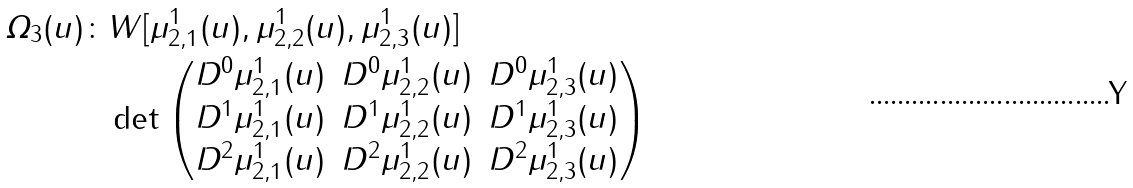Convert formula to latex. <formula><loc_0><loc_0><loc_500><loc_500>\varOmega _ { 3 } ( u ) \colon & W [ \mu ^ { 1 } _ { 2 , 1 } ( u ) , \mu ^ { 1 } _ { 2 , 2 } ( u ) , \mu ^ { 1 } _ { 2 , 3 } ( u ) ] \\ & \det \begin{pmatrix} D ^ { 0 } \mu ^ { 1 } _ { 2 , 1 } ( u ) & D ^ { 0 } \mu ^ { 1 } _ { 2 , 2 } ( u ) & D ^ { 0 } \mu ^ { 1 } _ { 2 , 3 } ( u ) \\ D ^ { 1 } \mu ^ { 1 } _ { 2 , 1 } ( u ) & D ^ { 1 } \mu ^ { 1 } _ { 2 , 2 } ( u ) & D ^ { 1 } \mu ^ { 1 } _ { 2 , 3 } ( u ) \\ D ^ { 2 } \mu ^ { 1 } _ { 2 , 1 } ( u ) & D ^ { 2 } \mu ^ { 1 } _ { 2 , 2 } ( u ) & D ^ { 2 } \mu ^ { 1 } _ { 2 , 3 } ( u ) \\ \end{pmatrix}</formula> 